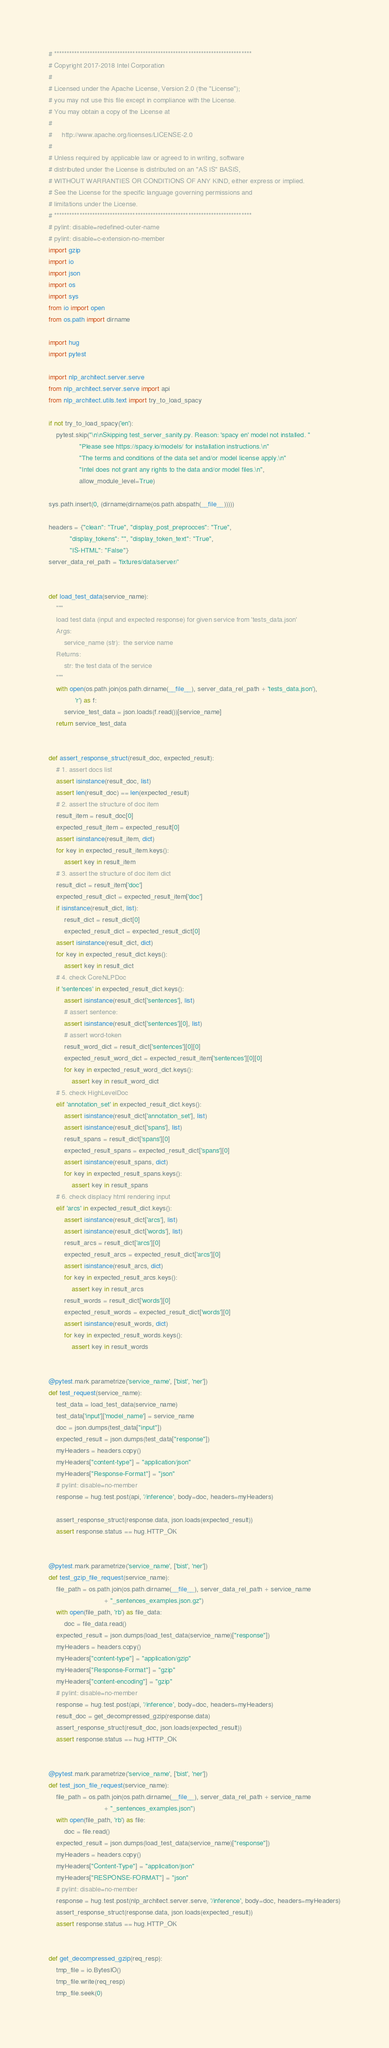<code> <loc_0><loc_0><loc_500><loc_500><_Python_># ******************************************************************************
# Copyright 2017-2018 Intel Corporation
#
# Licensed under the Apache License, Version 2.0 (the "License");
# you may not use this file except in compliance with the License.
# You may obtain a copy of the License at
#
#     http://www.apache.org/licenses/LICENSE-2.0
#
# Unless required by applicable law or agreed to in writing, software
# distributed under the License is distributed on an "AS IS" BASIS,
# WITHOUT WARRANTIES OR CONDITIONS OF ANY KIND, either express or implied.
# See the License for the specific language governing permissions and
# limitations under the License.
# ******************************************************************************
# pylint: disable=redefined-outer-name
# pylint: disable=c-extension-no-member
import gzip
import io
import json
import os
import sys
from io import open
from os.path import dirname

import hug
import pytest

import nlp_architect.server.serve
from nlp_architect.server.serve import api
from nlp_architect.utils.text import try_to_load_spacy

if not try_to_load_spacy('en'):
    pytest.skip("\n\nSkipping test_server_sanity.py. Reason: 'spacy en' model not installed. "
                "Please see https://spacy.io/models/ for installation instructions.\n"
                "The terms and conditions of the data set and/or model license apply.\n"
                "Intel does not grant any rights to the data and/or model files.\n",
                allow_module_level=True)

sys.path.insert(0, (dirname(dirname(os.path.abspath(__file__)))))

headers = {"clean": "True", "display_post_preprocces": "True",
           "display_tokens": "", "display_token_text": "True",
           "IS-HTML": "False"}
server_data_rel_path = 'fixtures/data/server/'


def load_test_data(service_name):
    """
    load test data (input and expected response) for given service from 'tests_data.json'
    Args:
        service_name (str):  the service name
    Returns:
        str: the test data of the service
    """
    with open(os.path.join(os.path.dirname(__file__), server_data_rel_path + 'tests_data.json'),
              'r') as f:
        service_test_data = json.loads(f.read())[service_name]
    return service_test_data


def assert_response_struct(result_doc, expected_result):
    # 1. assert docs list
    assert isinstance(result_doc, list)
    assert len(result_doc) == len(expected_result)
    # 2. assert the structure of doc item
    result_item = result_doc[0]
    expected_result_item = expected_result[0]
    assert isinstance(result_item, dict)
    for key in expected_result_item.keys():
        assert key in result_item
    # 3. assert the structure of doc item dict
    result_dict = result_item['doc']
    expected_result_dict = expected_result_item['doc']
    if isinstance(result_dict, list):
        result_dict = result_dict[0]
        expected_result_dict = expected_result_dict[0]
    assert isinstance(result_dict, dict)
    for key in expected_result_dict.keys():
        assert key in result_dict
    # 4. check CoreNLPDoc
    if 'sentences' in expected_result_dict.keys():
        assert isinstance(result_dict['sentences'], list)
        # assert sentence:
        assert isinstance(result_dict['sentences'][0], list)
        # assert word-token
        result_word_dict = result_dict['sentences'][0][0]
        expected_result_word_dict = expected_result_item['sentences'][0][0]
        for key in expected_result_word_dict.keys():
            assert key in result_word_dict
    # 5. check HighLevelDoc
    elif 'annotation_set' in expected_result_dict.keys():
        assert isinstance(result_dict['annotation_set'], list)
        assert isinstance(result_dict['spans'], list)
        result_spans = result_dict['spans'][0]
        expected_result_spans = expected_result_dict['spans'][0]
        assert isinstance(result_spans, dict)
        for key in expected_result_spans.keys():
            assert key in result_spans
    # 6. check displacy html rendering input
    elif 'arcs' in expected_result_dict.keys():
        assert isinstance(result_dict['arcs'], list)
        assert isinstance(result_dict['words'], list)
        result_arcs = result_dict['arcs'][0]
        expected_result_arcs = expected_result_dict['arcs'][0]
        assert isinstance(result_arcs, dict)
        for key in expected_result_arcs.keys():
            assert key in result_arcs
        result_words = result_dict['words'][0]
        expected_result_words = expected_result_dict['words'][0]
        assert isinstance(result_words, dict)
        for key in expected_result_words.keys():
            assert key in result_words


@pytest.mark.parametrize('service_name', ['bist', 'ner'])
def test_request(service_name):
    test_data = load_test_data(service_name)
    test_data['input']['model_name'] = service_name
    doc = json.dumps(test_data["input"])
    expected_result = json.dumps(test_data["response"])
    myHeaders = headers.copy()
    myHeaders["content-type"] = "application/json"
    myHeaders["Response-Format"] = "json"
    # pylint: disable=no-member
    response = hug.test.post(api, '/inference', body=doc, headers=myHeaders)

    assert_response_struct(response.data, json.loads(expected_result))
    assert response.status == hug.HTTP_OK


@pytest.mark.parametrize('service_name', ['bist', 'ner'])
def test_gzip_file_request(service_name):
    file_path = os.path.join(os.path.dirname(__file__), server_data_rel_path + service_name
                             + "_sentences_examples.json.gz")
    with open(file_path, 'rb') as file_data:
        doc = file_data.read()
    expected_result = json.dumps(load_test_data(service_name)["response"])
    myHeaders = headers.copy()
    myHeaders["content-type"] = "application/gzip"
    myHeaders["Response-Format"] = "gzip"
    myHeaders["content-encoding"] = "gzip"
    # pylint: disable=no-member
    response = hug.test.post(api, '/inference', body=doc, headers=myHeaders)
    result_doc = get_decompressed_gzip(response.data)
    assert_response_struct(result_doc, json.loads(expected_result))
    assert response.status == hug.HTTP_OK


@pytest.mark.parametrize('service_name', ['bist', 'ner'])
def test_json_file_request(service_name):
    file_path = os.path.join(os.path.dirname(__file__), server_data_rel_path + service_name
                             + "_sentences_examples.json")
    with open(file_path, 'rb') as file:
        doc = file.read()
    expected_result = json.dumps(load_test_data(service_name)["response"])
    myHeaders = headers.copy()
    myHeaders["Content-Type"] = "application/json"
    myHeaders["RESPONSE-FORMAT"] = "json"
    # pylint: disable=no-member
    response = hug.test.post(nlp_architect.server.serve, '/inference', body=doc, headers=myHeaders)
    assert_response_struct(response.data, json.loads(expected_result))
    assert response.status == hug.HTTP_OK


def get_decompressed_gzip(req_resp):
    tmp_file = io.BytesIO()
    tmp_file.write(req_resp)
    tmp_file.seek(0)</code> 